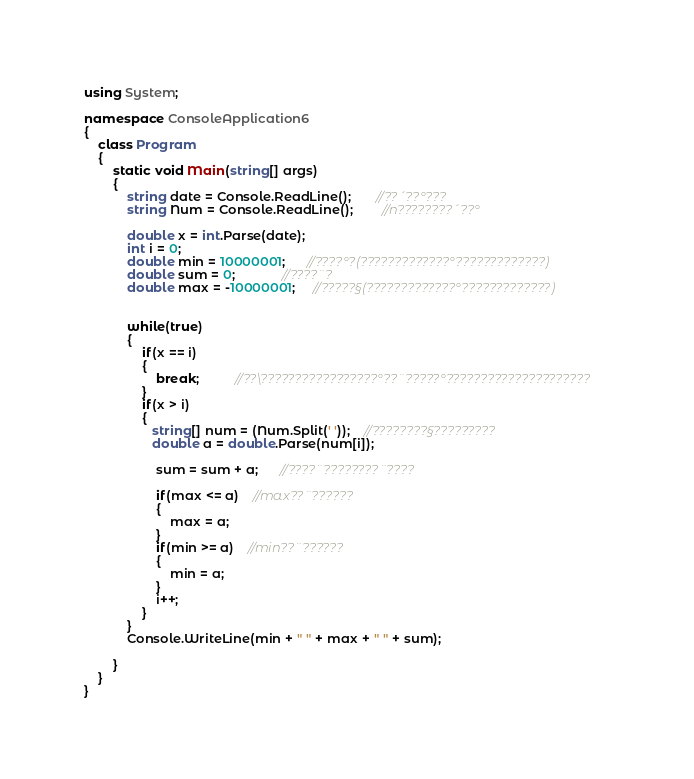<code> <loc_0><loc_0><loc_500><loc_500><_C#_>using System;

namespace ConsoleApplication6
{
    class Program
    {
        static void Main(string[] args)
        {
            string date = Console.ReadLine();       //??´??°???
            string Num = Console.ReadLine();        //n????????´??°

            double x = int.Parse(date);
            int i = 0;
            double min = 10000001;      //????°?(?????????????°?????????????)
            double sum = 0;             //????¨?
            double max = -10000001;     //?????§(?????????????°?????????????)


            while(true)
            {
                if(x == i)
                {
                    break;          //??\?????????????????°??¨?????°?????????????????????
                }
                if(x > i)
                {
                   string[] num = (Num.Split(' '));    //????????§?????????
                   double a = double.Parse(num[i]);

                    sum = sum + a;      //????¨????????¨????

                    if(max <= a)    //max??¨??????
                    {
                        max = a;
                    }
                    if(min >= a)    //min??¨??????
                    {
                        min = a;
                    }
                    i++;
                }
            }
            Console.WriteLine(min + " " + max + " " + sum);

        }
    }
}</code> 